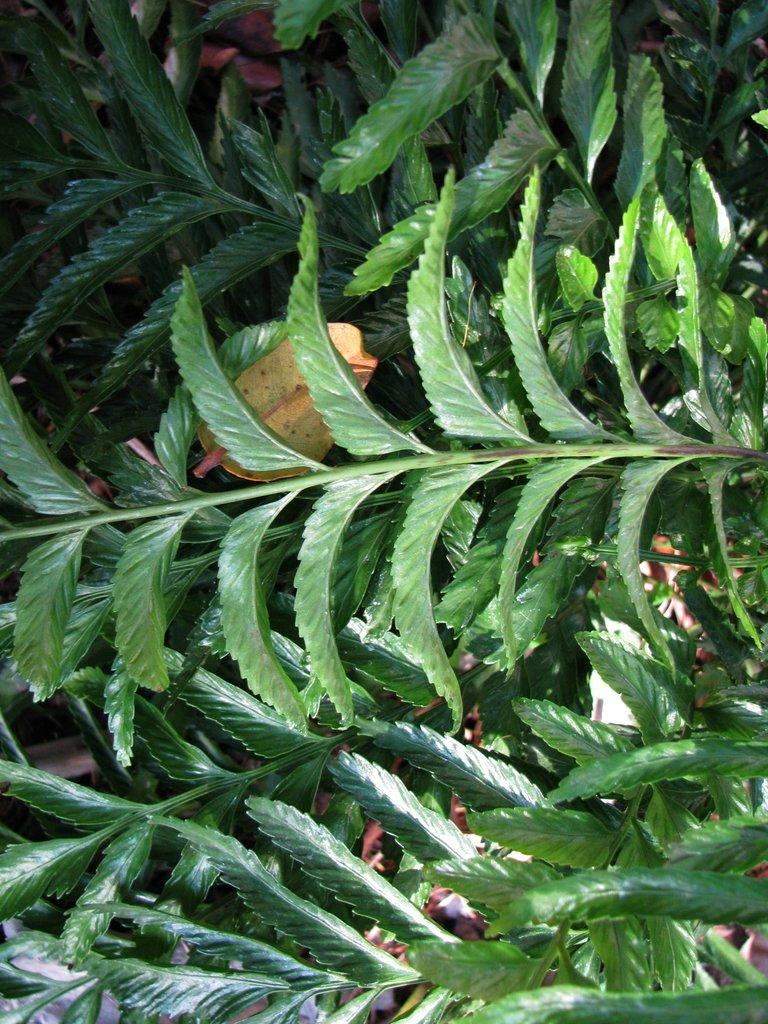What type of vegetation is present in the image? There is a tree and a plant in the image. Can you describe any specific features of the tree? There is a yellow color leaf in the middle of the tree. How many geese are sitting on the yellow color leaf in the image? There are no geese present in the image, and the yellow color leaf is part of the tree, not a separate object. 